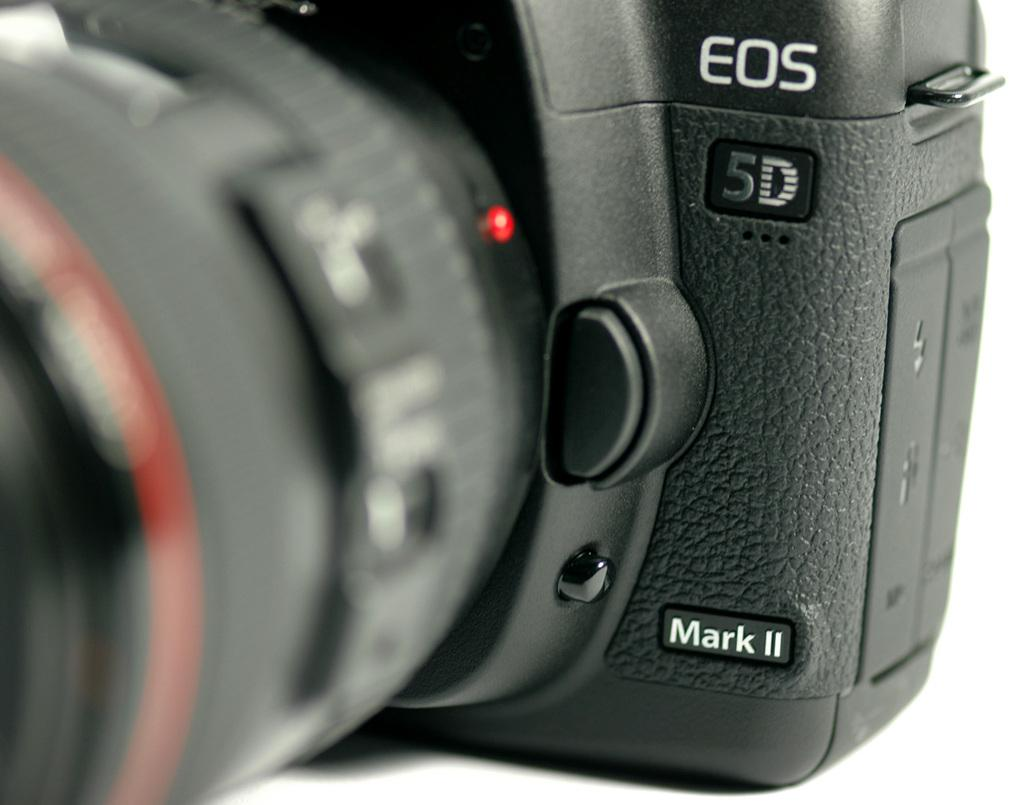What is the main subject in the foreground of the image? There is a camera in the foreground of the image. What type of dress is the camera wearing in the image? Cameras do not wear dresses, as they are inanimate objects. 